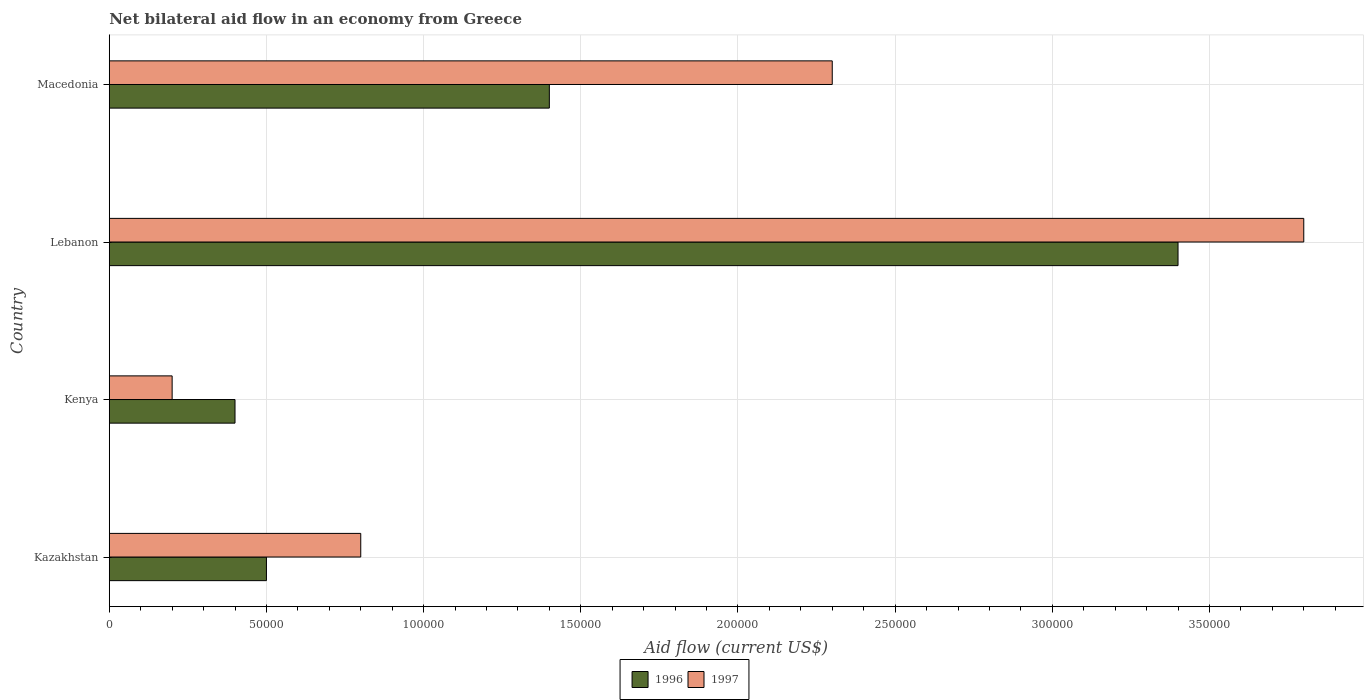Are the number of bars per tick equal to the number of legend labels?
Make the answer very short. Yes. How many bars are there on the 4th tick from the top?
Your answer should be very brief. 2. How many bars are there on the 4th tick from the bottom?
Give a very brief answer. 2. What is the label of the 3rd group of bars from the top?
Provide a succinct answer. Kenya. In how many cases, is the number of bars for a given country not equal to the number of legend labels?
Your answer should be very brief. 0. In which country was the net bilateral aid flow in 1996 maximum?
Your answer should be very brief. Lebanon. In which country was the net bilateral aid flow in 1997 minimum?
Your response must be concise. Kenya. What is the total net bilateral aid flow in 1996 in the graph?
Provide a short and direct response. 5.70e+05. What is the difference between the net bilateral aid flow in 1997 in Kenya and that in Lebanon?
Give a very brief answer. -3.60e+05. What is the difference between the net bilateral aid flow in 1996 in Kazakhstan and the net bilateral aid flow in 1997 in Kenya?
Offer a terse response. 3.00e+04. What is the average net bilateral aid flow in 1997 per country?
Make the answer very short. 1.78e+05. What is the difference between the net bilateral aid flow in 1996 and net bilateral aid flow in 1997 in Lebanon?
Provide a short and direct response. -4.00e+04. In how many countries, is the net bilateral aid flow in 1996 greater than 50000 US$?
Provide a short and direct response. 2. What is the ratio of the net bilateral aid flow in 1997 in Kazakhstan to that in Lebanon?
Give a very brief answer. 0.21. Is the difference between the net bilateral aid flow in 1996 in Kenya and Macedonia greater than the difference between the net bilateral aid flow in 1997 in Kenya and Macedonia?
Keep it short and to the point. Yes. What is the difference between the highest and the second highest net bilateral aid flow in 1996?
Give a very brief answer. 2.00e+05. What is the difference between the highest and the lowest net bilateral aid flow in 1996?
Offer a terse response. 3.00e+05. Is the sum of the net bilateral aid flow in 1996 in Kazakhstan and Lebanon greater than the maximum net bilateral aid flow in 1997 across all countries?
Give a very brief answer. Yes. How many bars are there?
Ensure brevity in your answer.  8. How many countries are there in the graph?
Your answer should be compact. 4. What is the difference between two consecutive major ticks on the X-axis?
Offer a terse response. 5.00e+04. How many legend labels are there?
Provide a short and direct response. 2. What is the title of the graph?
Keep it short and to the point. Net bilateral aid flow in an economy from Greece. Does "1969" appear as one of the legend labels in the graph?
Your answer should be compact. No. What is the label or title of the X-axis?
Your answer should be compact. Aid flow (current US$). What is the label or title of the Y-axis?
Make the answer very short. Country. What is the Aid flow (current US$) in 1996 in Kazakhstan?
Your answer should be very brief. 5.00e+04. What is the Aid flow (current US$) in 1997 in Kenya?
Your answer should be compact. 2.00e+04. What is the Aid flow (current US$) in 1996 in Lebanon?
Your answer should be very brief. 3.40e+05. What is the Aid flow (current US$) in 1997 in Lebanon?
Keep it short and to the point. 3.80e+05. What is the Aid flow (current US$) in 1996 in Macedonia?
Your answer should be compact. 1.40e+05. What is the Aid flow (current US$) of 1997 in Macedonia?
Your answer should be very brief. 2.30e+05. Across all countries, what is the minimum Aid flow (current US$) of 1997?
Provide a short and direct response. 2.00e+04. What is the total Aid flow (current US$) of 1996 in the graph?
Your response must be concise. 5.70e+05. What is the total Aid flow (current US$) of 1997 in the graph?
Your answer should be very brief. 7.10e+05. What is the difference between the Aid flow (current US$) in 1997 in Kazakhstan and that in Kenya?
Ensure brevity in your answer.  6.00e+04. What is the difference between the Aid flow (current US$) in 1997 in Kazakhstan and that in Lebanon?
Your response must be concise. -3.00e+05. What is the difference between the Aid flow (current US$) in 1996 in Kazakhstan and that in Macedonia?
Provide a short and direct response. -9.00e+04. What is the difference between the Aid flow (current US$) in 1996 in Kenya and that in Lebanon?
Your answer should be compact. -3.00e+05. What is the difference between the Aid flow (current US$) in 1997 in Kenya and that in Lebanon?
Make the answer very short. -3.60e+05. What is the difference between the Aid flow (current US$) of 1997 in Kenya and that in Macedonia?
Provide a short and direct response. -2.10e+05. What is the difference between the Aid flow (current US$) of 1996 in Lebanon and that in Macedonia?
Offer a terse response. 2.00e+05. What is the difference between the Aid flow (current US$) of 1997 in Lebanon and that in Macedonia?
Your answer should be compact. 1.50e+05. What is the difference between the Aid flow (current US$) in 1996 in Kazakhstan and the Aid flow (current US$) in 1997 in Lebanon?
Make the answer very short. -3.30e+05. What is the difference between the Aid flow (current US$) of 1996 in Kenya and the Aid flow (current US$) of 1997 in Lebanon?
Keep it short and to the point. -3.40e+05. What is the difference between the Aid flow (current US$) in 1996 in Kenya and the Aid flow (current US$) in 1997 in Macedonia?
Your response must be concise. -1.90e+05. What is the average Aid flow (current US$) in 1996 per country?
Offer a very short reply. 1.42e+05. What is the average Aid flow (current US$) in 1997 per country?
Your answer should be compact. 1.78e+05. What is the difference between the Aid flow (current US$) of 1996 and Aid flow (current US$) of 1997 in Kenya?
Ensure brevity in your answer.  2.00e+04. What is the difference between the Aid flow (current US$) of 1996 and Aid flow (current US$) of 1997 in Lebanon?
Provide a succinct answer. -4.00e+04. What is the ratio of the Aid flow (current US$) in 1996 in Kazakhstan to that in Kenya?
Make the answer very short. 1.25. What is the ratio of the Aid flow (current US$) of 1996 in Kazakhstan to that in Lebanon?
Your answer should be compact. 0.15. What is the ratio of the Aid flow (current US$) of 1997 in Kazakhstan to that in Lebanon?
Offer a very short reply. 0.21. What is the ratio of the Aid flow (current US$) of 1996 in Kazakhstan to that in Macedonia?
Provide a short and direct response. 0.36. What is the ratio of the Aid flow (current US$) of 1997 in Kazakhstan to that in Macedonia?
Provide a succinct answer. 0.35. What is the ratio of the Aid flow (current US$) in 1996 in Kenya to that in Lebanon?
Keep it short and to the point. 0.12. What is the ratio of the Aid flow (current US$) of 1997 in Kenya to that in Lebanon?
Your response must be concise. 0.05. What is the ratio of the Aid flow (current US$) in 1996 in Kenya to that in Macedonia?
Your answer should be very brief. 0.29. What is the ratio of the Aid flow (current US$) in 1997 in Kenya to that in Macedonia?
Keep it short and to the point. 0.09. What is the ratio of the Aid flow (current US$) of 1996 in Lebanon to that in Macedonia?
Provide a short and direct response. 2.43. What is the ratio of the Aid flow (current US$) in 1997 in Lebanon to that in Macedonia?
Provide a short and direct response. 1.65. What is the difference between the highest and the second highest Aid flow (current US$) in 1996?
Provide a succinct answer. 2.00e+05. What is the difference between the highest and the lowest Aid flow (current US$) in 1997?
Ensure brevity in your answer.  3.60e+05. 